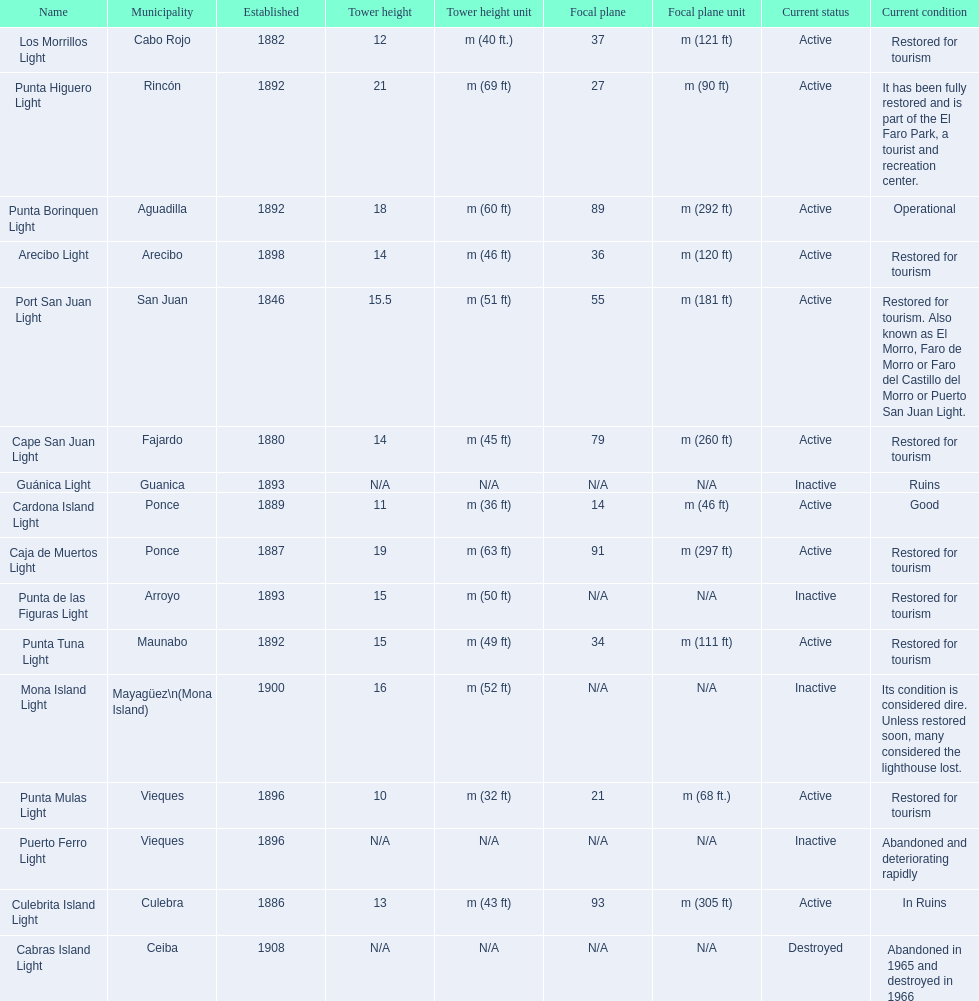How many towers are at least 18 meters tall? 3. 